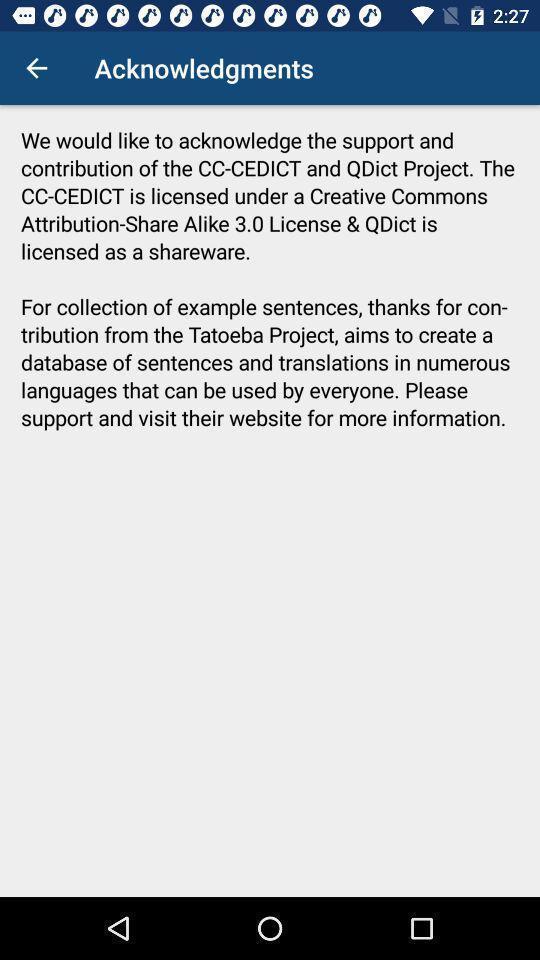Please provide a description for this image. Welcome page for display information. 